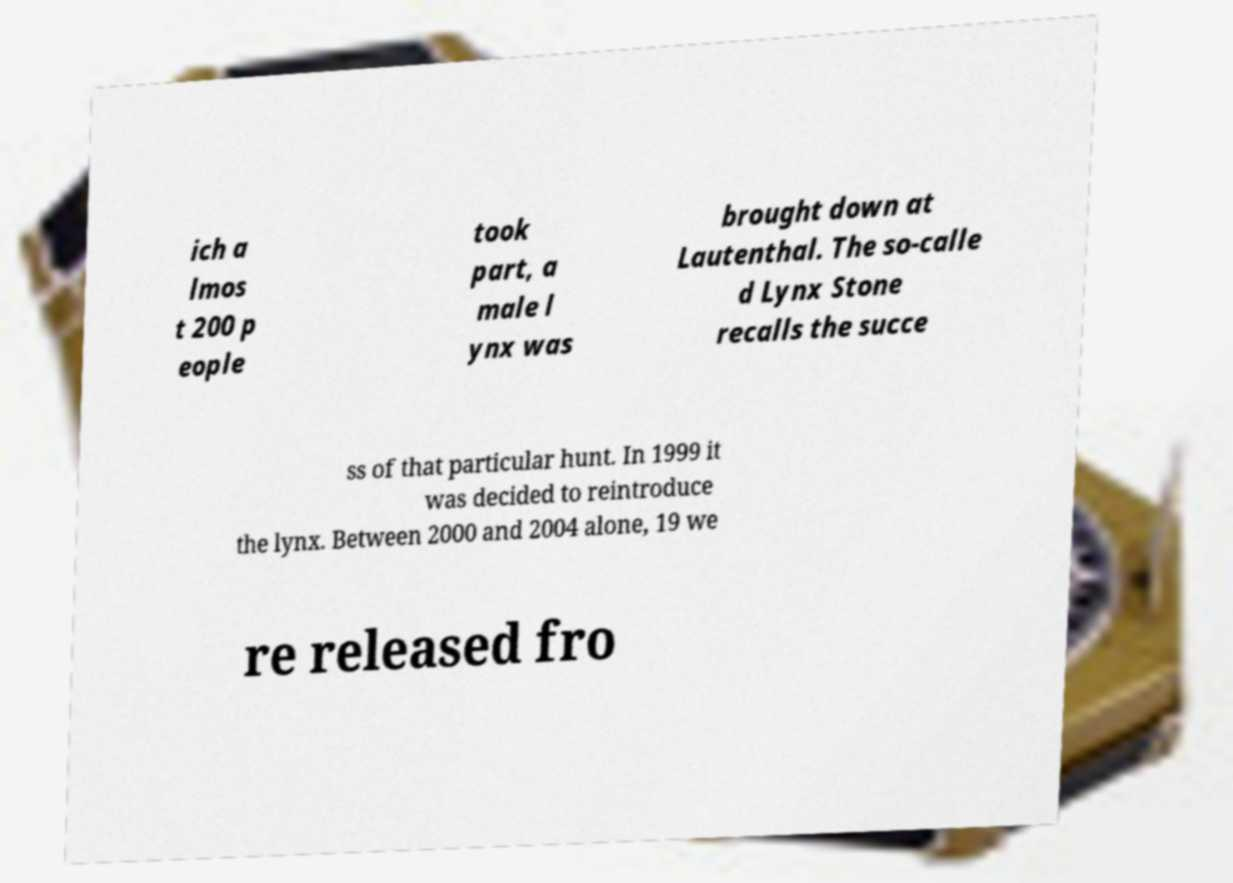Please read and relay the text visible in this image. What does it say? ich a lmos t 200 p eople took part, a male l ynx was brought down at Lautenthal. The so-calle d Lynx Stone recalls the succe ss of that particular hunt. In 1999 it was decided to reintroduce the lynx. Between 2000 and 2004 alone, 19 we re released fro 